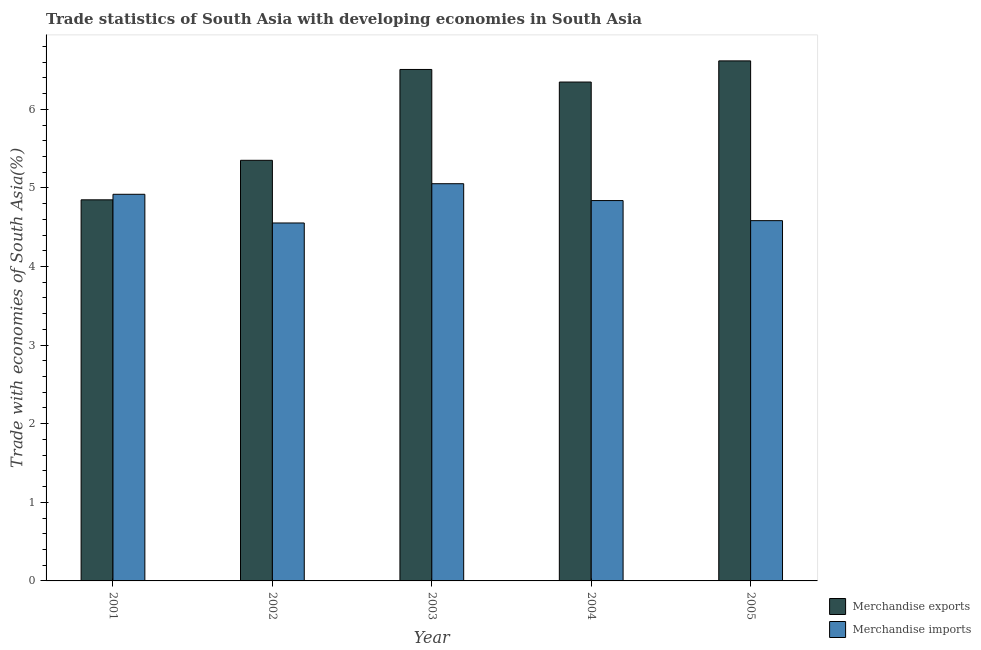How many groups of bars are there?
Your response must be concise. 5. Are the number of bars per tick equal to the number of legend labels?
Offer a very short reply. Yes. How many bars are there on the 1st tick from the left?
Your response must be concise. 2. How many bars are there on the 2nd tick from the right?
Make the answer very short. 2. In how many cases, is the number of bars for a given year not equal to the number of legend labels?
Offer a very short reply. 0. What is the merchandise exports in 2003?
Offer a terse response. 6.51. Across all years, what is the maximum merchandise exports?
Offer a very short reply. 6.62. Across all years, what is the minimum merchandise imports?
Provide a succinct answer. 4.55. What is the total merchandise exports in the graph?
Provide a short and direct response. 29.67. What is the difference between the merchandise imports in 2004 and that in 2005?
Your response must be concise. 0.26. What is the difference between the merchandise imports in 2004 and the merchandise exports in 2002?
Offer a terse response. 0.29. What is the average merchandise exports per year?
Offer a very short reply. 5.93. In the year 2001, what is the difference between the merchandise exports and merchandise imports?
Ensure brevity in your answer.  0. In how many years, is the merchandise imports greater than 0.4 %?
Keep it short and to the point. 5. What is the ratio of the merchandise imports in 2001 to that in 2002?
Give a very brief answer. 1.08. Is the merchandise imports in 2003 less than that in 2005?
Provide a short and direct response. No. Is the difference between the merchandise imports in 2003 and 2004 greater than the difference between the merchandise exports in 2003 and 2004?
Make the answer very short. No. What is the difference between the highest and the second highest merchandise exports?
Provide a succinct answer. 0.11. What is the difference between the highest and the lowest merchandise imports?
Ensure brevity in your answer.  0.5. In how many years, is the merchandise imports greater than the average merchandise imports taken over all years?
Ensure brevity in your answer.  3. Is the sum of the merchandise imports in 2002 and 2005 greater than the maximum merchandise exports across all years?
Give a very brief answer. Yes. How many years are there in the graph?
Offer a very short reply. 5. What is the difference between two consecutive major ticks on the Y-axis?
Provide a short and direct response. 1. Are the values on the major ticks of Y-axis written in scientific E-notation?
Offer a very short reply. No. Does the graph contain any zero values?
Ensure brevity in your answer.  No. Does the graph contain grids?
Provide a succinct answer. No. How many legend labels are there?
Offer a very short reply. 2. What is the title of the graph?
Keep it short and to the point. Trade statistics of South Asia with developing economies in South Asia. What is the label or title of the X-axis?
Provide a succinct answer. Year. What is the label or title of the Y-axis?
Keep it short and to the point. Trade with economies of South Asia(%). What is the Trade with economies of South Asia(%) in Merchandise exports in 2001?
Make the answer very short. 4.85. What is the Trade with economies of South Asia(%) of Merchandise imports in 2001?
Your answer should be very brief. 4.92. What is the Trade with economies of South Asia(%) in Merchandise exports in 2002?
Offer a terse response. 5.35. What is the Trade with economies of South Asia(%) in Merchandise imports in 2002?
Offer a very short reply. 4.55. What is the Trade with economies of South Asia(%) in Merchandise exports in 2003?
Your answer should be compact. 6.51. What is the Trade with economies of South Asia(%) of Merchandise imports in 2003?
Keep it short and to the point. 5.05. What is the Trade with economies of South Asia(%) in Merchandise exports in 2004?
Provide a short and direct response. 6.35. What is the Trade with economies of South Asia(%) of Merchandise imports in 2004?
Offer a terse response. 4.84. What is the Trade with economies of South Asia(%) in Merchandise exports in 2005?
Your response must be concise. 6.62. What is the Trade with economies of South Asia(%) in Merchandise imports in 2005?
Offer a very short reply. 4.58. Across all years, what is the maximum Trade with economies of South Asia(%) in Merchandise exports?
Make the answer very short. 6.62. Across all years, what is the maximum Trade with economies of South Asia(%) of Merchandise imports?
Ensure brevity in your answer.  5.05. Across all years, what is the minimum Trade with economies of South Asia(%) of Merchandise exports?
Your answer should be very brief. 4.85. Across all years, what is the minimum Trade with economies of South Asia(%) in Merchandise imports?
Offer a terse response. 4.55. What is the total Trade with economies of South Asia(%) of Merchandise exports in the graph?
Make the answer very short. 29.67. What is the total Trade with economies of South Asia(%) of Merchandise imports in the graph?
Your answer should be compact. 23.95. What is the difference between the Trade with economies of South Asia(%) in Merchandise exports in 2001 and that in 2002?
Make the answer very short. -0.5. What is the difference between the Trade with economies of South Asia(%) in Merchandise imports in 2001 and that in 2002?
Give a very brief answer. 0.36. What is the difference between the Trade with economies of South Asia(%) in Merchandise exports in 2001 and that in 2003?
Keep it short and to the point. -1.66. What is the difference between the Trade with economies of South Asia(%) in Merchandise imports in 2001 and that in 2003?
Give a very brief answer. -0.13. What is the difference between the Trade with economies of South Asia(%) in Merchandise exports in 2001 and that in 2004?
Provide a short and direct response. -1.5. What is the difference between the Trade with economies of South Asia(%) in Merchandise imports in 2001 and that in 2004?
Make the answer very short. 0.08. What is the difference between the Trade with economies of South Asia(%) in Merchandise exports in 2001 and that in 2005?
Ensure brevity in your answer.  -1.77. What is the difference between the Trade with economies of South Asia(%) of Merchandise imports in 2001 and that in 2005?
Keep it short and to the point. 0.34. What is the difference between the Trade with economies of South Asia(%) of Merchandise exports in 2002 and that in 2003?
Provide a short and direct response. -1.16. What is the difference between the Trade with economies of South Asia(%) in Merchandise imports in 2002 and that in 2003?
Offer a terse response. -0.5. What is the difference between the Trade with economies of South Asia(%) of Merchandise exports in 2002 and that in 2004?
Offer a terse response. -1. What is the difference between the Trade with economies of South Asia(%) of Merchandise imports in 2002 and that in 2004?
Ensure brevity in your answer.  -0.28. What is the difference between the Trade with economies of South Asia(%) in Merchandise exports in 2002 and that in 2005?
Offer a very short reply. -1.26. What is the difference between the Trade with economies of South Asia(%) of Merchandise imports in 2002 and that in 2005?
Offer a terse response. -0.03. What is the difference between the Trade with economies of South Asia(%) of Merchandise exports in 2003 and that in 2004?
Your answer should be compact. 0.16. What is the difference between the Trade with economies of South Asia(%) of Merchandise imports in 2003 and that in 2004?
Offer a terse response. 0.21. What is the difference between the Trade with economies of South Asia(%) in Merchandise exports in 2003 and that in 2005?
Your answer should be very brief. -0.11. What is the difference between the Trade with economies of South Asia(%) of Merchandise imports in 2003 and that in 2005?
Ensure brevity in your answer.  0.47. What is the difference between the Trade with economies of South Asia(%) of Merchandise exports in 2004 and that in 2005?
Offer a terse response. -0.27. What is the difference between the Trade with economies of South Asia(%) in Merchandise imports in 2004 and that in 2005?
Your response must be concise. 0.26. What is the difference between the Trade with economies of South Asia(%) of Merchandise exports in 2001 and the Trade with economies of South Asia(%) of Merchandise imports in 2002?
Your answer should be very brief. 0.29. What is the difference between the Trade with economies of South Asia(%) of Merchandise exports in 2001 and the Trade with economies of South Asia(%) of Merchandise imports in 2003?
Ensure brevity in your answer.  -0.21. What is the difference between the Trade with economies of South Asia(%) of Merchandise exports in 2001 and the Trade with economies of South Asia(%) of Merchandise imports in 2004?
Provide a short and direct response. 0.01. What is the difference between the Trade with economies of South Asia(%) of Merchandise exports in 2001 and the Trade with economies of South Asia(%) of Merchandise imports in 2005?
Make the answer very short. 0.27. What is the difference between the Trade with economies of South Asia(%) in Merchandise exports in 2002 and the Trade with economies of South Asia(%) in Merchandise imports in 2003?
Provide a short and direct response. 0.3. What is the difference between the Trade with economies of South Asia(%) of Merchandise exports in 2002 and the Trade with economies of South Asia(%) of Merchandise imports in 2004?
Provide a succinct answer. 0.51. What is the difference between the Trade with economies of South Asia(%) in Merchandise exports in 2002 and the Trade with economies of South Asia(%) in Merchandise imports in 2005?
Offer a terse response. 0.77. What is the difference between the Trade with economies of South Asia(%) of Merchandise exports in 2003 and the Trade with economies of South Asia(%) of Merchandise imports in 2004?
Offer a very short reply. 1.67. What is the difference between the Trade with economies of South Asia(%) of Merchandise exports in 2003 and the Trade with economies of South Asia(%) of Merchandise imports in 2005?
Offer a terse response. 1.92. What is the difference between the Trade with economies of South Asia(%) in Merchandise exports in 2004 and the Trade with economies of South Asia(%) in Merchandise imports in 2005?
Provide a short and direct response. 1.76. What is the average Trade with economies of South Asia(%) of Merchandise exports per year?
Provide a short and direct response. 5.93. What is the average Trade with economies of South Asia(%) of Merchandise imports per year?
Give a very brief answer. 4.79. In the year 2001, what is the difference between the Trade with economies of South Asia(%) of Merchandise exports and Trade with economies of South Asia(%) of Merchandise imports?
Your answer should be compact. -0.07. In the year 2002, what is the difference between the Trade with economies of South Asia(%) of Merchandise exports and Trade with economies of South Asia(%) of Merchandise imports?
Your answer should be compact. 0.8. In the year 2003, what is the difference between the Trade with economies of South Asia(%) of Merchandise exports and Trade with economies of South Asia(%) of Merchandise imports?
Provide a succinct answer. 1.45. In the year 2004, what is the difference between the Trade with economies of South Asia(%) in Merchandise exports and Trade with economies of South Asia(%) in Merchandise imports?
Give a very brief answer. 1.51. In the year 2005, what is the difference between the Trade with economies of South Asia(%) in Merchandise exports and Trade with economies of South Asia(%) in Merchandise imports?
Your answer should be compact. 2.03. What is the ratio of the Trade with economies of South Asia(%) of Merchandise exports in 2001 to that in 2002?
Provide a succinct answer. 0.91. What is the ratio of the Trade with economies of South Asia(%) in Merchandise imports in 2001 to that in 2002?
Provide a short and direct response. 1.08. What is the ratio of the Trade with economies of South Asia(%) of Merchandise exports in 2001 to that in 2003?
Your answer should be very brief. 0.75. What is the ratio of the Trade with economies of South Asia(%) in Merchandise imports in 2001 to that in 2003?
Your answer should be compact. 0.97. What is the ratio of the Trade with economies of South Asia(%) of Merchandise exports in 2001 to that in 2004?
Provide a short and direct response. 0.76. What is the ratio of the Trade with economies of South Asia(%) of Merchandise imports in 2001 to that in 2004?
Offer a very short reply. 1.02. What is the ratio of the Trade with economies of South Asia(%) in Merchandise exports in 2001 to that in 2005?
Keep it short and to the point. 0.73. What is the ratio of the Trade with economies of South Asia(%) of Merchandise imports in 2001 to that in 2005?
Keep it short and to the point. 1.07. What is the ratio of the Trade with economies of South Asia(%) of Merchandise exports in 2002 to that in 2003?
Your response must be concise. 0.82. What is the ratio of the Trade with economies of South Asia(%) in Merchandise imports in 2002 to that in 2003?
Offer a terse response. 0.9. What is the ratio of the Trade with economies of South Asia(%) of Merchandise exports in 2002 to that in 2004?
Make the answer very short. 0.84. What is the ratio of the Trade with economies of South Asia(%) of Merchandise imports in 2002 to that in 2004?
Give a very brief answer. 0.94. What is the ratio of the Trade with economies of South Asia(%) of Merchandise exports in 2002 to that in 2005?
Make the answer very short. 0.81. What is the ratio of the Trade with economies of South Asia(%) in Merchandise exports in 2003 to that in 2004?
Give a very brief answer. 1.03. What is the ratio of the Trade with economies of South Asia(%) of Merchandise imports in 2003 to that in 2004?
Make the answer very short. 1.04. What is the ratio of the Trade with economies of South Asia(%) of Merchandise exports in 2003 to that in 2005?
Provide a succinct answer. 0.98. What is the ratio of the Trade with economies of South Asia(%) in Merchandise imports in 2003 to that in 2005?
Provide a short and direct response. 1.1. What is the ratio of the Trade with economies of South Asia(%) in Merchandise exports in 2004 to that in 2005?
Your response must be concise. 0.96. What is the ratio of the Trade with economies of South Asia(%) in Merchandise imports in 2004 to that in 2005?
Your answer should be compact. 1.06. What is the difference between the highest and the second highest Trade with economies of South Asia(%) in Merchandise exports?
Ensure brevity in your answer.  0.11. What is the difference between the highest and the second highest Trade with economies of South Asia(%) in Merchandise imports?
Your response must be concise. 0.13. What is the difference between the highest and the lowest Trade with economies of South Asia(%) of Merchandise exports?
Keep it short and to the point. 1.77. What is the difference between the highest and the lowest Trade with economies of South Asia(%) of Merchandise imports?
Give a very brief answer. 0.5. 